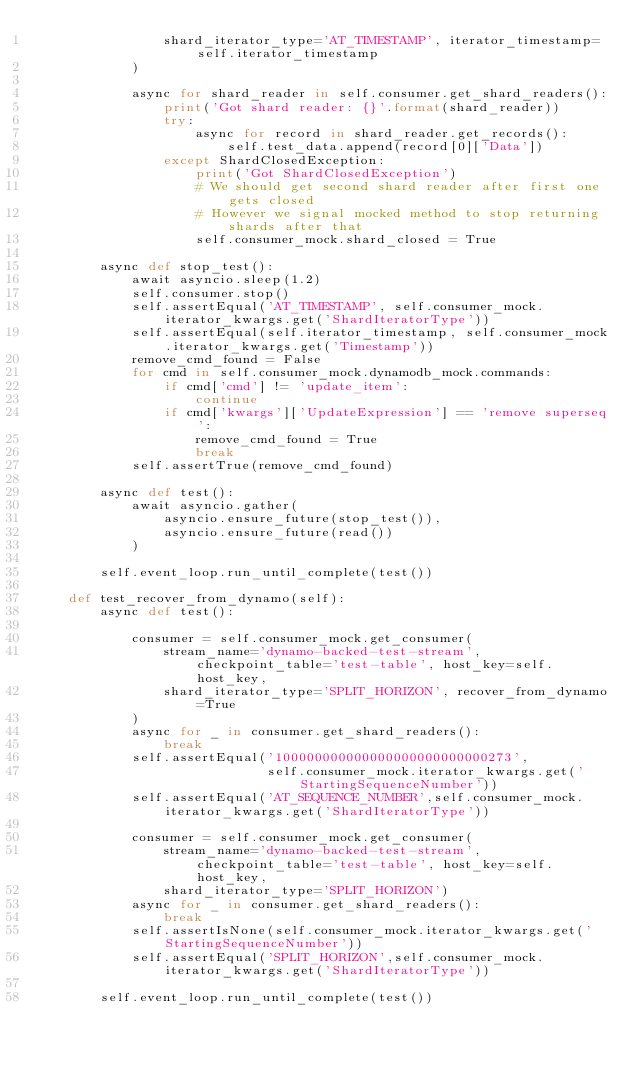<code> <loc_0><loc_0><loc_500><loc_500><_Python_>                shard_iterator_type='AT_TIMESTAMP', iterator_timestamp=self.iterator_timestamp
            )

            async for shard_reader in self.consumer.get_shard_readers():
                print('Got shard reader: {}'.format(shard_reader))
                try:
                    async for record in shard_reader.get_records():
                        self.test_data.append(record[0]['Data'])
                except ShardClosedException:
                    print('Got ShardClosedException')
                    # We should get second shard reader after first one gets closed
                    # However we signal mocked method to stop returning shards after that
                    self.consumer_mock.shard_closed = True

        async def stop_test():
            await asyncio.sleep(1.2)
            self.consumer.stop()
            self.assertEqual('AT_TIMESTAMP', self.consumer_mock.iterator_kwargs.get('ShardIteratorType'))
            self.assertEqual(self.iterator_timestamp, self.consumer_mock.iterator_kwargs.get('Timestamp'))
            remove_cmd_found = False
            for cmd in self.consumer_mock.dynamodb_mock.commands:
                if cmd['cmd'] != 'update_item':
                    continue
                if cmd['kwargs']['UpdateExpression'] == 'remove superseq':
                    remove_cmd_found = True
                    break
            self.assertTrue(remove_cmd_found)

        async def test():
            await asyncio.gather(
                asyncio.ensure_future(stop_test()),
                asyncio.ensure_future(read())
            )

        self.event_loop.run_until_complete(test())

    def test_recover_from_dynamo(self):
        async def test():

            consumer = self.consumer_mock.get_consumer(
                stream_name='dynamo-backed-test-stream', checkpoint_table='test-table', host_key=self.host_key,
                shard_iterator_type='SPLIT_HORIZON', recover_from_dynamo=True
            )
            async for _ in consumer.get_shard_readers():
                break
            self.assertEqual('100000000000000000000000000273',
                             self.consumer_mock.iterator_kwargs.get('StartingSequenceNumber'))
            self.assertEqual('AT_SEQUENCE_NUMBER',self.consumer_mock.iterator_kwargs.get('ShardIteratorType'))

            consumer = self.consumer_mock.get_consumer(
                stream_name='dynamo-backed-test-stream', checkpoint_table='test-table', host_key=self.host_key,
                shard_iterator_type='SPLIT_HORIZON')
            async for _ in consumer.get_shard_readers():
                break
            self.assertIsNone(self.consumer_mock.iterator_kwargs.get('StartingSequenceNumber'))
            self.assertEqual('SPLIT_HORIZON',self.consumer_mock.iterator_kwargs.get('ShardIteratorType'))

        self.event_loop.run_until_complete(test())</code> 